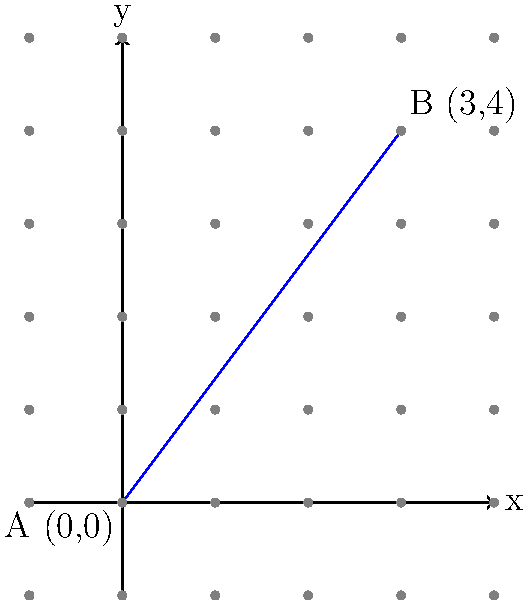In a podcast discussion about Natasha Lyonne's life, you mention that her birthplace (New York City) and current residence (Los Angeles) can be represented on a coordinate plane. If New York City is at point A (0,0) and Los Angeles is at point B (3,4), what is the straight-line distance between these two cities? Use the distance formula and round your answer to two decimal places. To solve this problem, we'll use the distance formula derived from the Pythagorean theorem:

$$d = \sqrt{(x_2 - x_1)^2 + (y_2 - y_1)^2}$$

Where $(x_1, y_1)$ represents the coordinates of point A (New York City) and $(x_2, y_2)$ represents the coordinates of point B (Los Angeles).

Step 1: Identify the coordinates
- Point A (New York City): $(x_1, y_1) = (0, 0)$
- Point B (Los Angeles): $(x_2, y_2) = (3, 4)$

Step 2: Plug the coordinates into the distance formula
$$d = \sqrt{(3 - 0)^2 + (4 - 0)^2}$$

Step 3: Simplify the expressions inside the parentheses
$$d = \sqrt{3^2 + 4^2}$$

Step 4: Calculate the squares
$$d = \sqrt{9 + 16}$$

Step 5: Add the numbers under the square root
$$d = \sqrt{25}$$

Step 6: Calculate the square root
$$d = 5$$

Therefore, the straight-line distance between New York City and Los Angeles on this coordinate plane is 5 units.
Answer: 5 units 